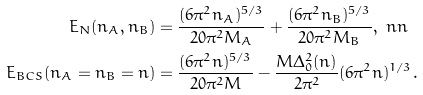Convert formula to latex. <formula><loc_0><loc_0><loc_500><loc_500>E _ { N } ( n _ { A } , n _ { B } ) & = \frac { ( 6 \pi ^ { 2 } n _ { A } ) ^ { 5 / 3 } } { 2 0 \pi ^ { 2 } M _ { A } } + \frac { ( 6 \pi ^ { 2 } n _ { B } ) ^ { 5 / 3 } } { 2 0 \pi ^ { 2 } M _ { B } } , \ n n \\ E _ { B C S } ( n _ { A } = n _ { B } = n ) & = \frac { ( 6 \pi ^ { 2 } n ) ^ { 5 / 3 } } { 2 0 \pi ^ { 2 } M } - \frac { M \Delta _ { 0 } ^ { 2 } ( n ) } { 2 \pi ^ { 2 } } ( 6 \pi ^ { 2 } n ) ^ { 1 / 3 } .</formula> 